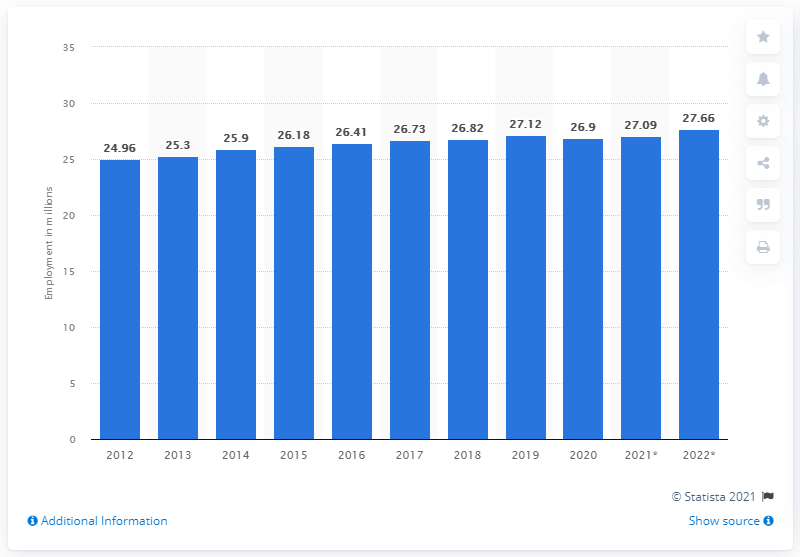Specify some key components in this picture. The employment in South Korea ended in 2020. As of the year 2020, the period of employment in South Korea has come to an end. In 2020, the number of people employed in South Korea was 27,090,000. 